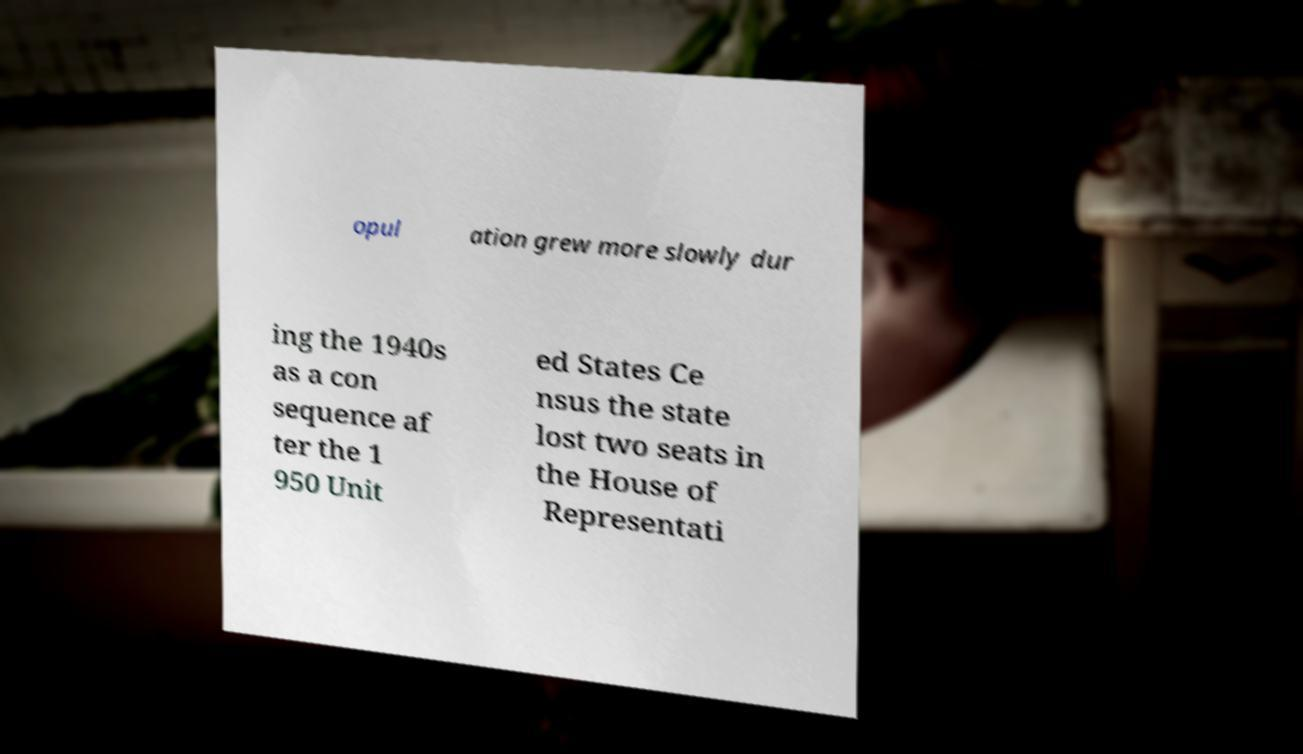There's text embedded in this image that I need extracted. Can you transcribe it verbatim? opul ation grew more slowly dur ing the 1940s as a con sequence af ter the 1 950 Unit ed States Ce nsus the state lost two seats in the House of Representati 